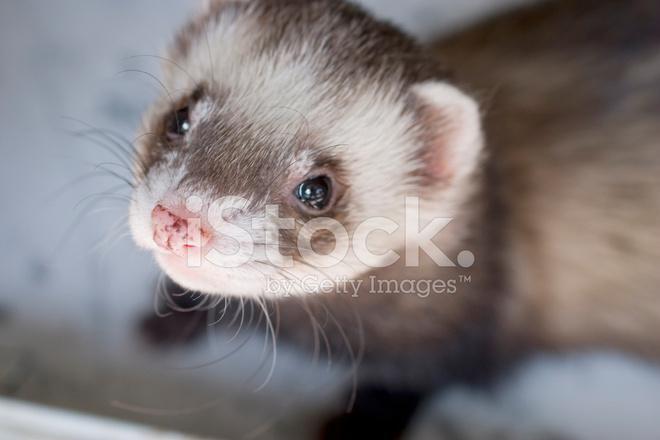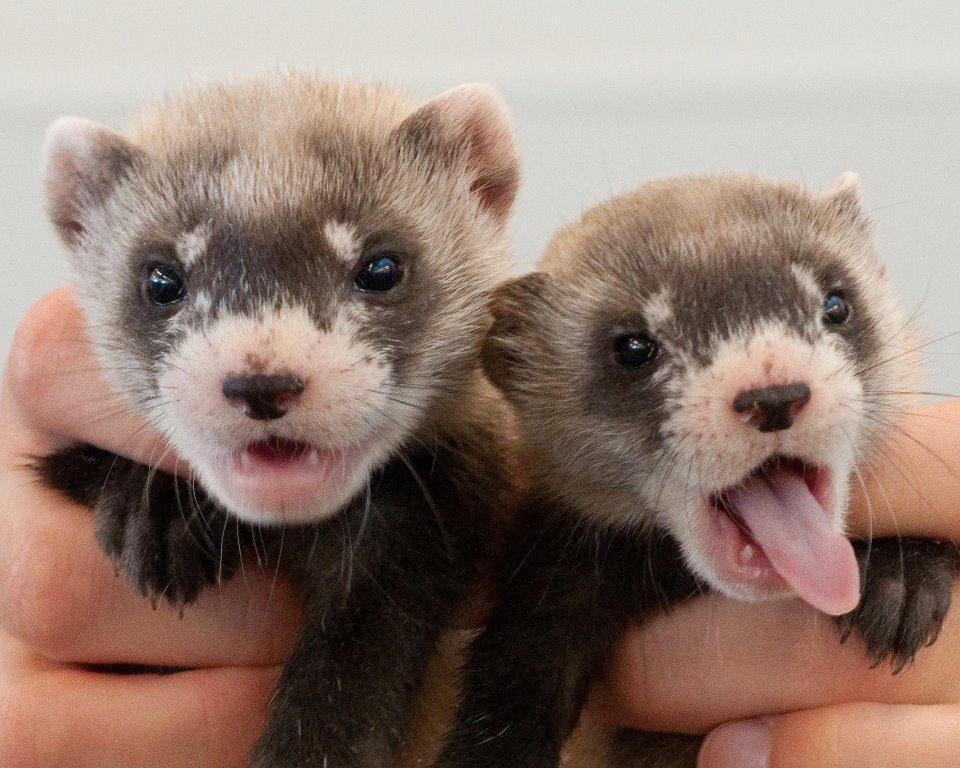The first image is the image on the left, the second image is the image on the right. Examine the images to the left and right. Is the description "at least one animal has its mouth open" accurate? Answer yes or no. Yes. 